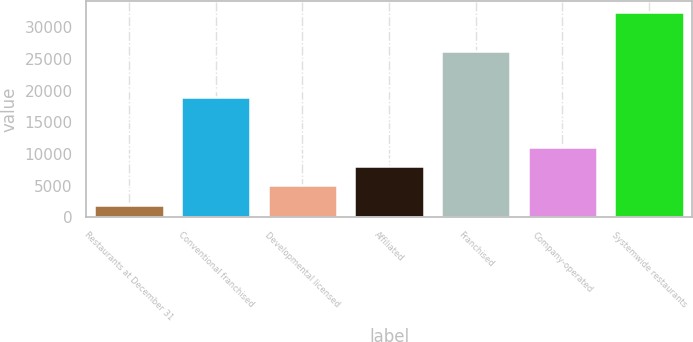<chart> <loc_0><loc_0><loc_500><loc_500><bar_chart><fcel>Restaurants at December 31<fcel>Conventional franchised<fcel>Developmental licensed<fcel>Affiliated<fcel>Franchised<fcel>Company-operated<fcel>Systemwide restaurants<nl><fcel>2009<fcel>19020<fcel>5055.9<fcel>8102.8<fcel>26216<fcel>11149.7<fcel>32478<nl></chart> 